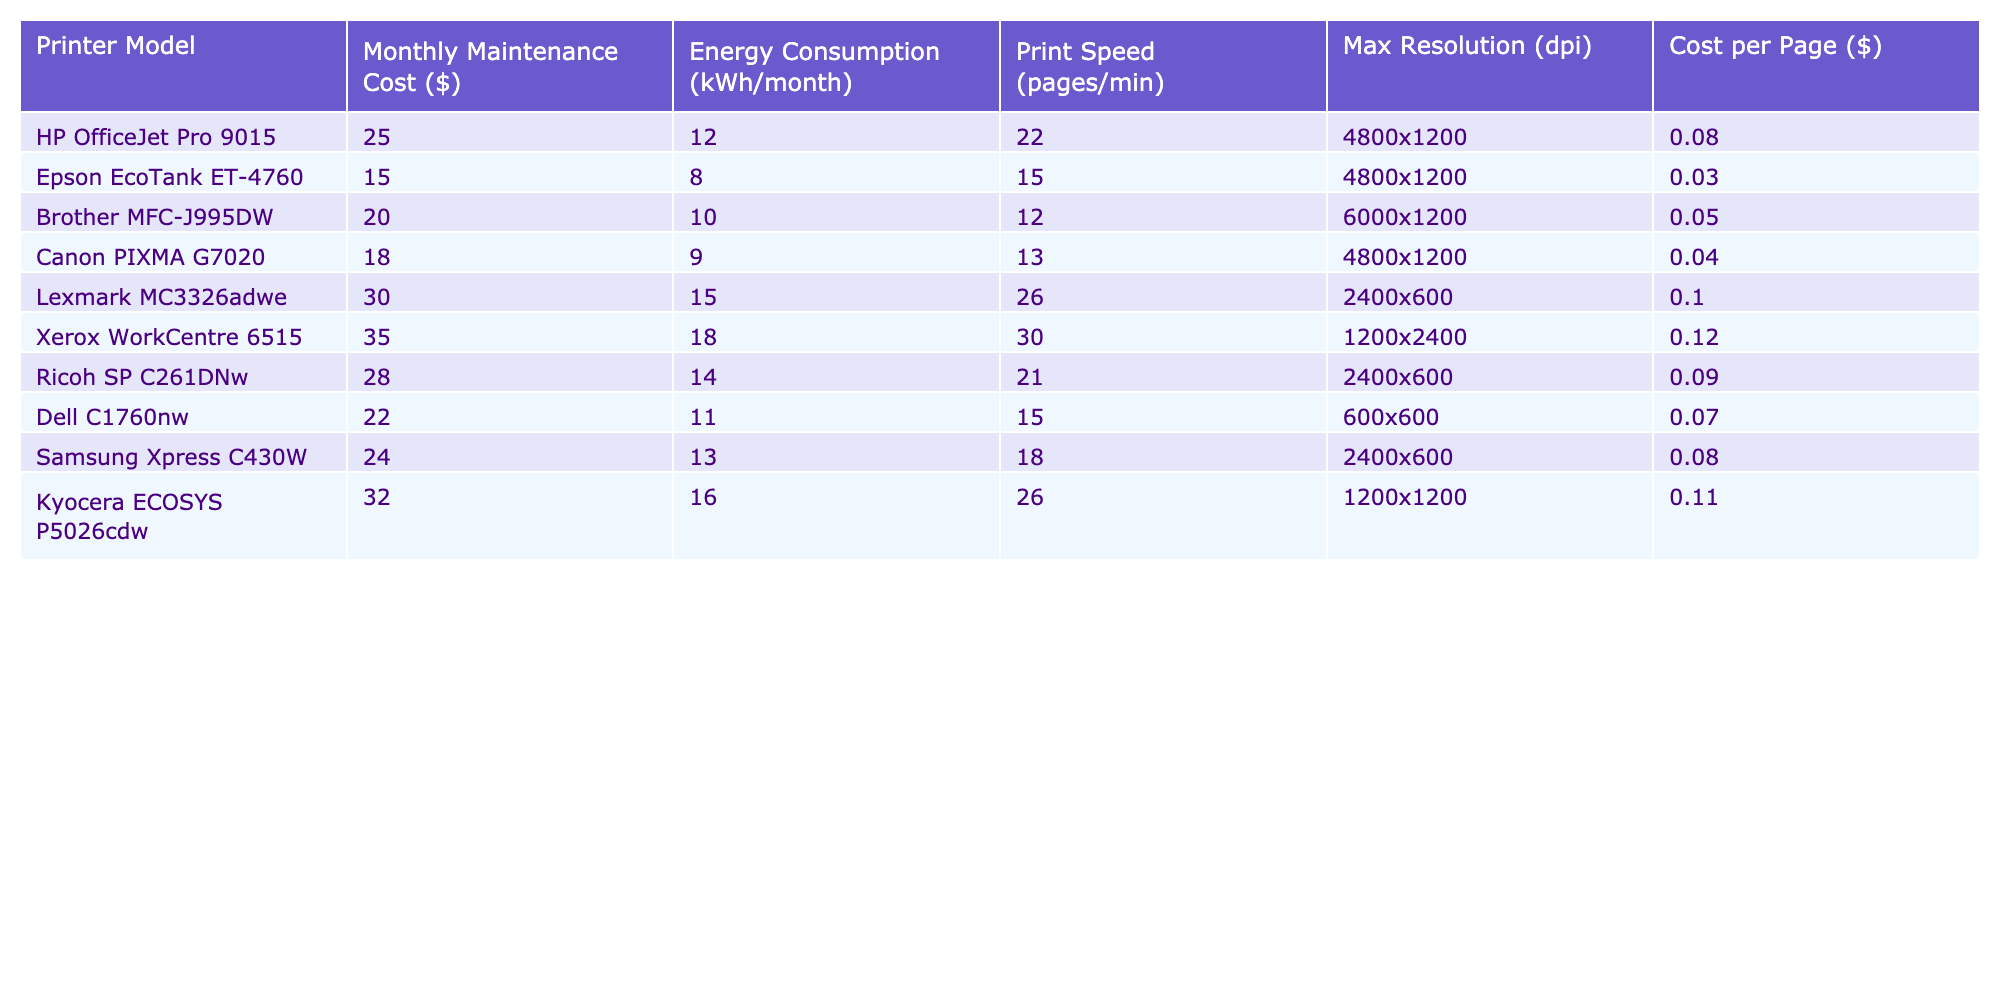What is the monthly maintenance cost of the Epson EcoTank ET-4760? The table lists the monthly maintenance cost of each printer model. For the Epson EcoTank ET-4760, it is specified as $15.
Answer: $15 Which printer has the highest energy consumption per month? By comparing the energy consumption values in the table for each printer, the Xerox WorkCentre 6515 has the highest consumption at 18 kWh/month.
Answer: Xerox WorkCentre 6515 What is the monthly maintenance cost difference between the HP OfficeJet Pro 9015 and the Brother MFC-J995DW? The monthly maintenance cost of the HP OfficeJet Pro 9015 is $25 and for the Brother MFC-J995DW, it is $20. The difference is $25 - $20 = $5.
Answer: $5 Is the cost per page for the Canon PIXMA G7020 lower than that for the Kyocera ECOSYS P5026cdw? The table shows that the cost per page for the Canon PIXMA G7020 is $0.04, while for the Kyocera ECOSYS P5026cdw, it is $0.11. Since $0.04 is less than $0.11, the statement is true.
Answer: Yes What is the average monthly maintenance cost of all the printers listed in the table? To find the average, sum the maintenance costs: $25 + $15 + $20 + $18 + $30 + $35 + $28 + $22 + $24 + $32 = $229. There are 10 printers, so the average is $229 / 10 = $22.9.
Answer: $22.9 Which printer model offers the best print speed relative to its monthly maintenance cost? To analyze this, calculate the print speed per dollar of maintenance for each printer. The highest ratio found is for the Lexmark MC3326adwe at 0.87 pages per dollar ($30/26 pages). This is the best ratio indicating good value for print speed.
Answer: Lexmark MC3326adwe How much less does the Brother MFC-J995DW spend on maintenance compared to the Dell C1760nw? The Brother MFC-J995DW's monthly maintenance cost is $20, while the Dell C1760nw's is $22. The difference is $22 - $20 = $2.
Answer: $2 What is the maximum resolution of the printer with the lowest monthly maintenance cost? The printer with the lowest maintenance cost is the Epson EcoTank ET-4760, which has a maximum resolution of 4800x1200 dpi.
Answer: 4800x1200 dpi Are there any printers that have both energy consumption and monthly maintenance cost below $20? By examining the table, the Epson EcoTank ET-4760 has both a monthly maintenance cost of $15 and an energy consumption of 8 kWh/month, confirming the existence of such printers.
Answer: Yes Which printer has the best combination of low maintenance cost and medium print speed? The Canon PIXMA G7020 has a maintenance cost of $18 and a print speed of 13 pages/min, which reflects a balanced combination of affordability and efficiency compared to others.
Answer: Canon PIXMA G7020 